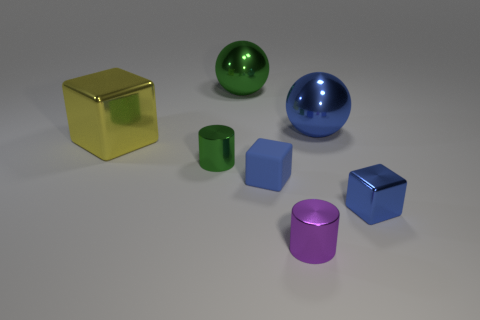How many objects are there in total, and can you categorize them by color and shape? There are seven objects in the image. Categorizing by color, there is one yellow, one green, one blue, two purple, and two blue objects. By shape, there is one cube, one sphere, two cylinders, and three other various shaped objects similar to cubes but with different numbers of faces visible. 